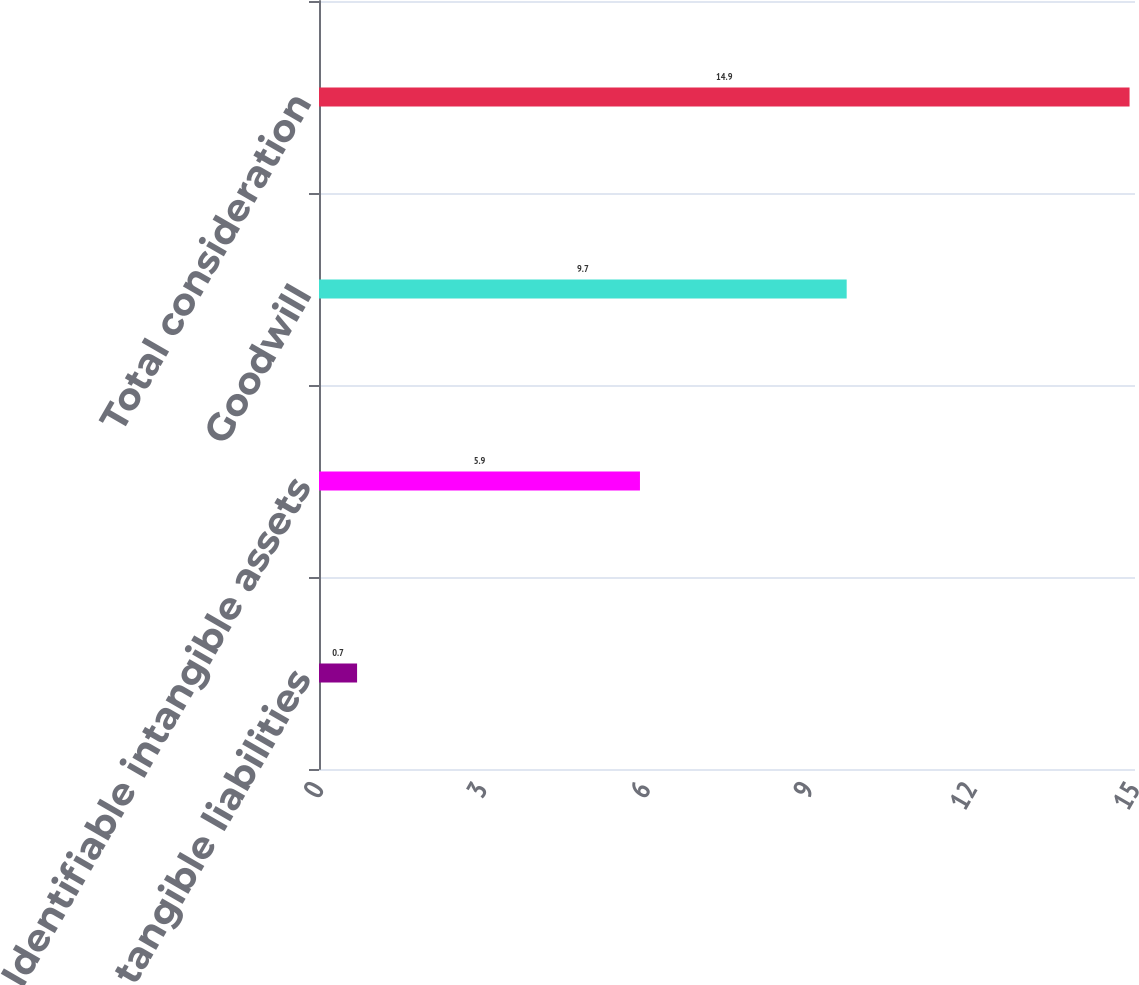Convert chart to OTSL. <chart><loc_0><loc_0><loc_500><loc_500><bar_chart><fcel>Net tangible liabilities<fcel>Identifiable intangible assets<fcel>Goodwill<fcel>Total consideration<nl><fcel>0.7<fcel>5.9<fcel>9.7<fcel>14.9<nl></chart> 